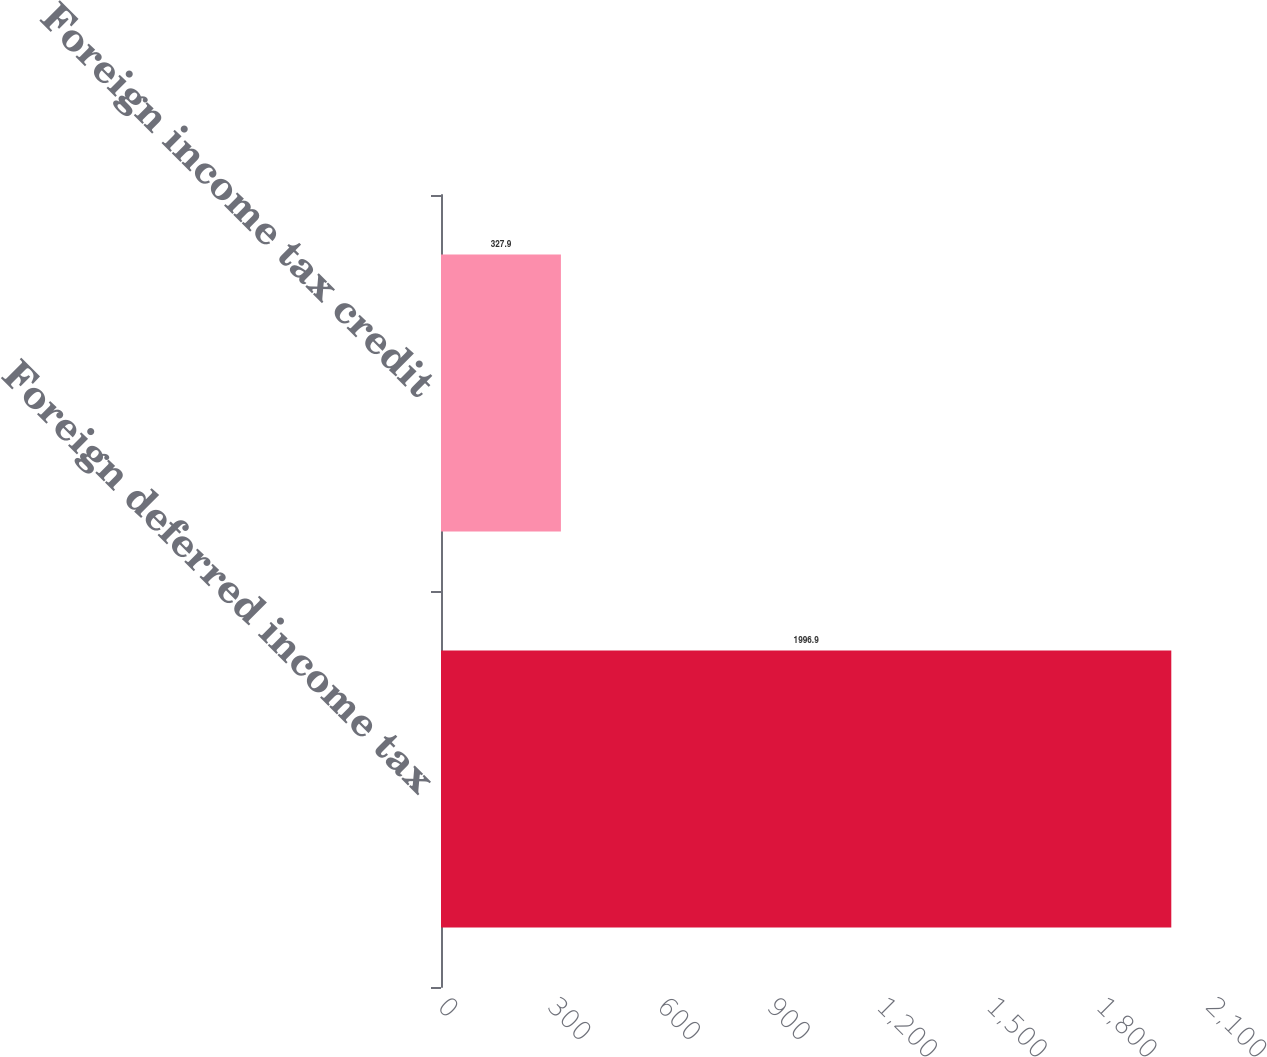<chart> <loc_0><loc_0><loc_500><loc_500><bar_chart><fcel>Foreign deferred income tax<fcel>Foreign income tax credit<nl><fcel>1996.9<fcel>327.9<nl></chart> 